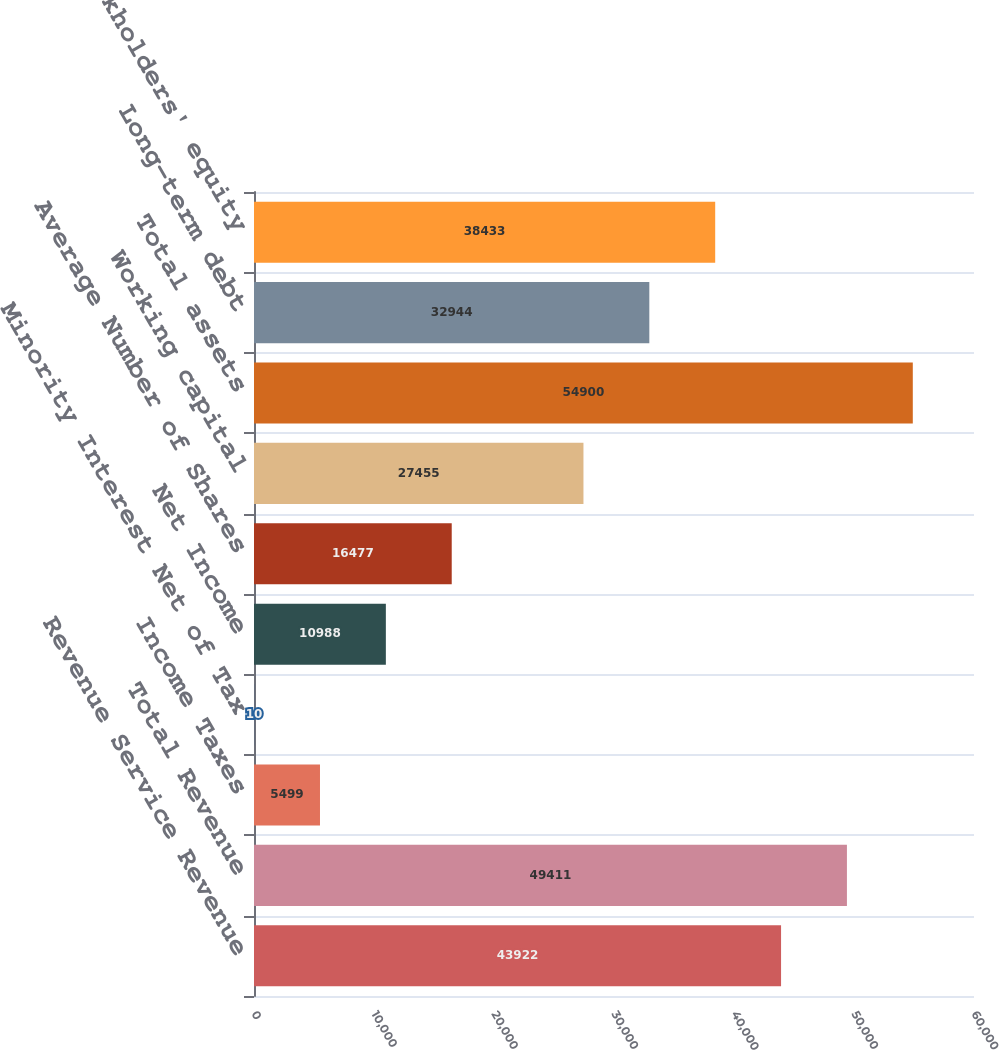Convert chart to OTSL. <chart><loc_0><loc_0><loc_500><loc_500><bar_chart><fcel>Revenue Service Revenue<fcel>Total Revenue<fcel>Income Taxes<fcel>Minority Interest Net of Tax<fcel>Net Income<fcel>Average Number of Shares<fcel>Working capital<fcel>Total assets<fcel>Long-term debt<fcel>Stockholders' equity<nl><fcel>43922<fcel>49411<fcel>5499<fcel>10<fcel>10988<fcel>16477<fcel>27455<fcel>54900<fcel>32944<fcel>38433<nl></chart> 